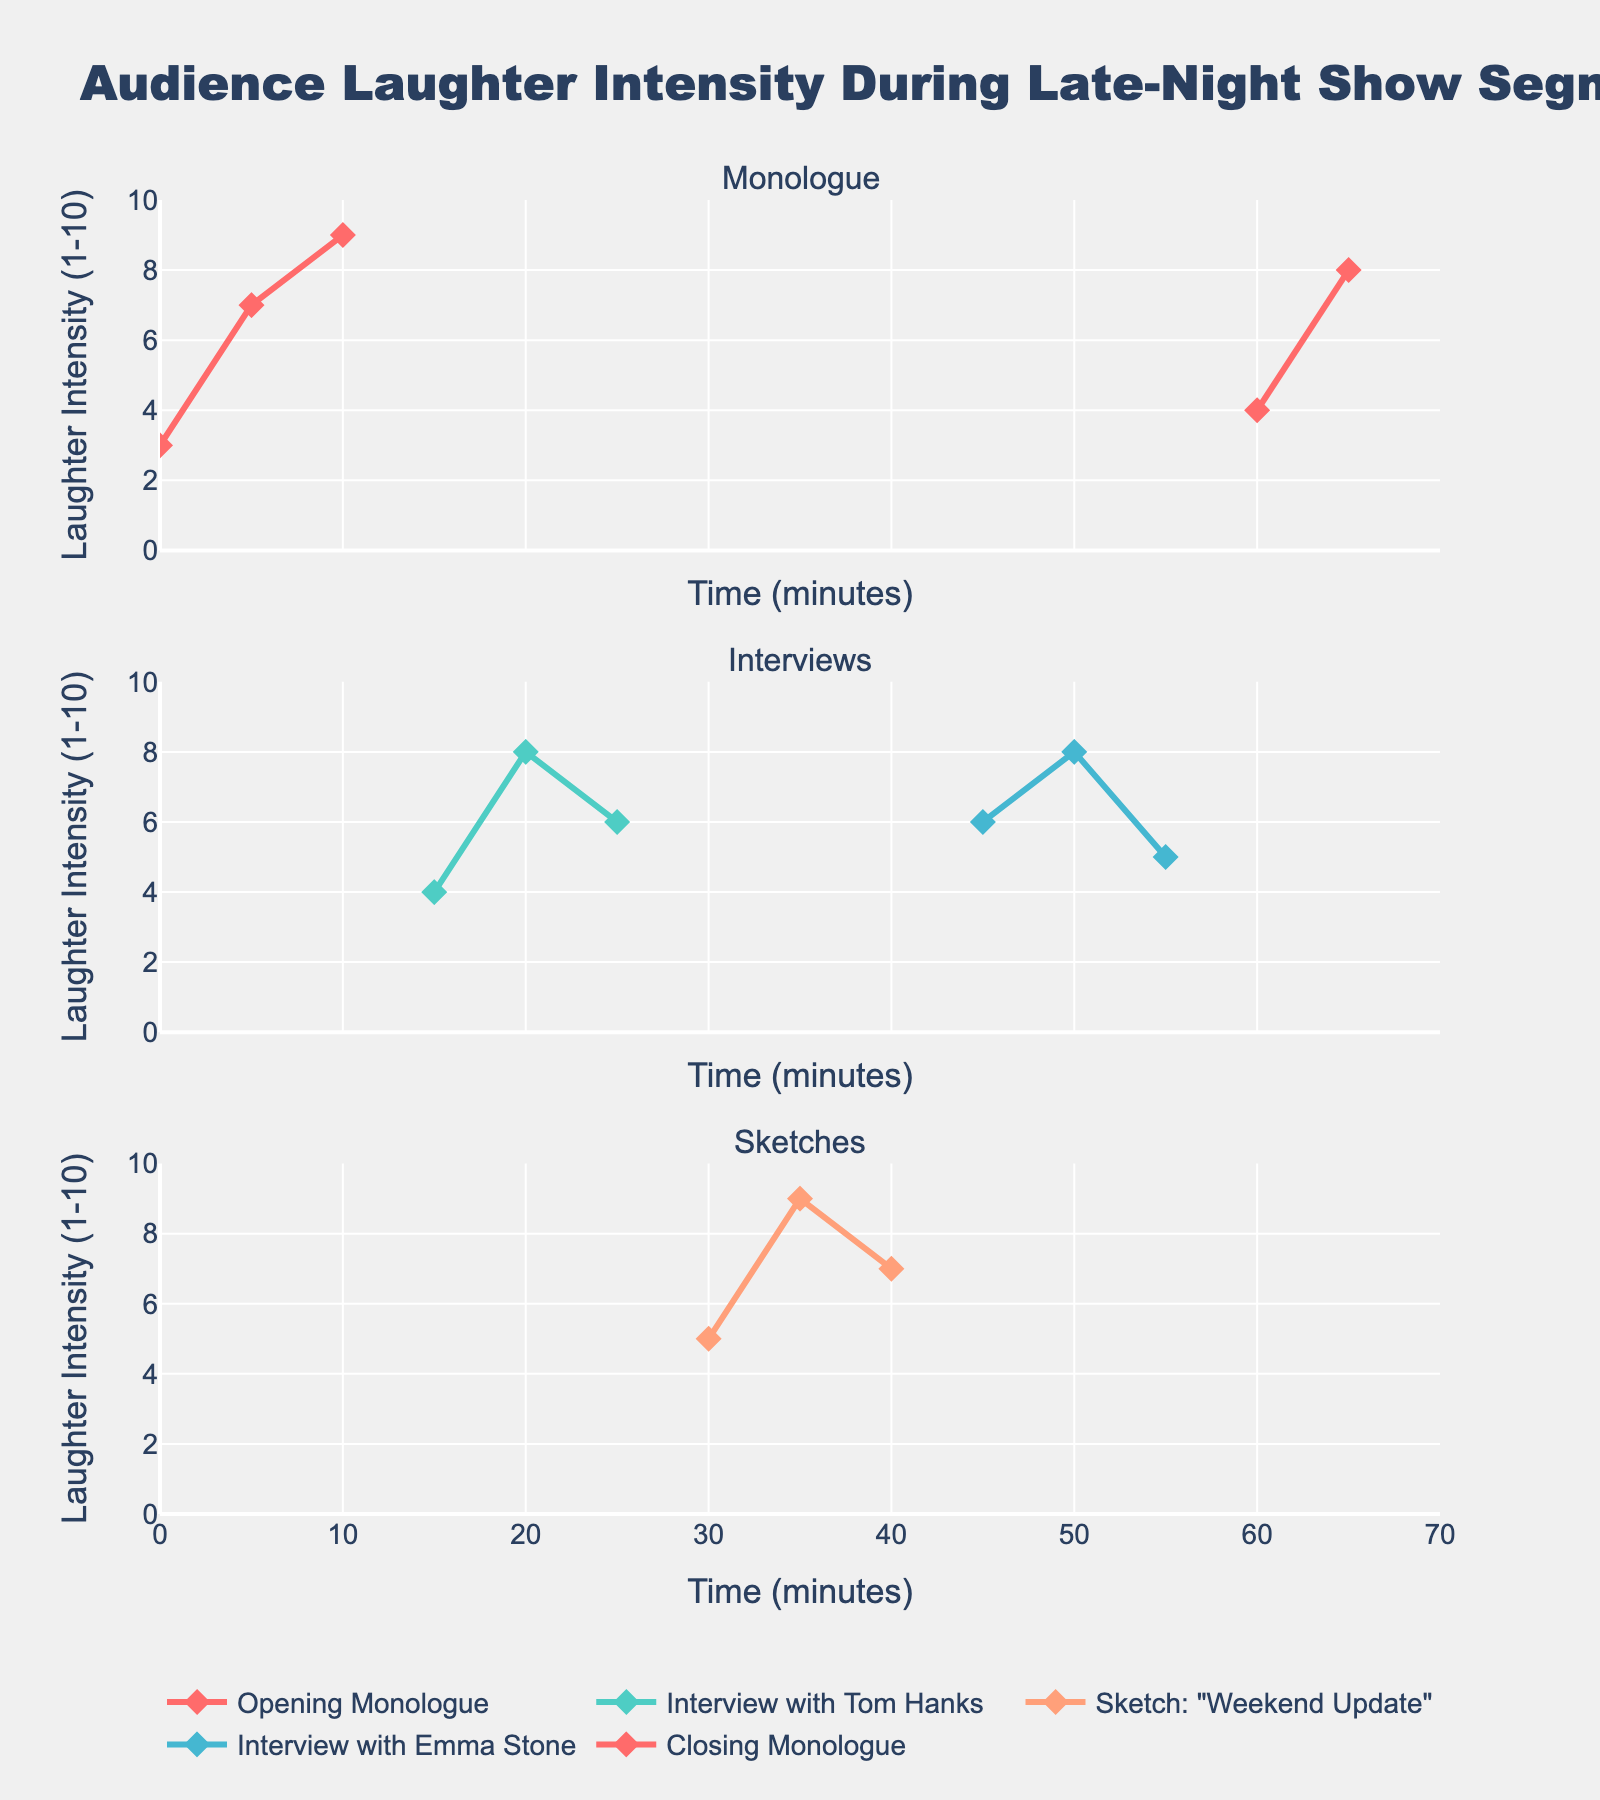What's the title of the plot? The title of the plot is located at the top of the figure and reads "Audience Laughter Intensity During Late-Night Show Segments".
Answer: Audience Laughter Intensity During Late-Night Show Segments How many segments are displayed in the figure? The figure displays five segments: Opening Monologue, Interview with Tom Hanks, Sketch "Weekend Update", Interview with Emma Stone, and Closing Monologue.
Answer: 5 What's the highest laughter intensity recorded during the Sketch "Weekend Update"? For the Sketch "Weekend Update", the laughter intensities are 5, 9, and 7. The highest among these is 9.
Answer: 9 Between which two time points does the Opening Monologue show the highest increase in laughter intensity? The Opening Monologue segment shows data at 0, 5, and 10 minutes with laughter intensities of 3, 7, and 9 respectively. The highest increase is between 0 to 5 minutes where intensity increases by 4 (7-3).
Answer: 0 to 5 minutes Which interview segment exhibits more fluctuation in laughter intensity? The Interview with Tom Hanks has laughter intensities of 4, 8, and 6, while Interview with Emma Stone has 6, 8, and 5. The fluctuation range for Tom Hanks is 4 (8-4) and for Emma Stone is 3 (8-5). Hence, Interview with Tom Hanks has more fluctuation.
Answer: Interview with Tom Hanks What is the average laughter intensity during the Interview with Emma Stone? Laughter intensities during the Interview with Emma Stone are 6, 8, and 5. Their sum is 19, and the average is 19/3 ≈ 6.33.
Answer: 6.33 Which monologue segment, Opening or Closing, has a higher average laughter intensity? The Opening Monologue laughter intensities are 3, 7, and 9. Average = (3+7+9)/3 = 6.33. The Closing Monologue intensities are 4 and 8. Average = (4+8)/2 = 6. The Opening Monologue has a higher average.
Answer: Opening Monologue At what time point was the highest overall laughter intensity recorded? Checking all segments, the highest intensity recorded is 9, which appears at 10 minutes in the Opening Monologue and at 35 minutes in Sketch "Weekend Update".
Answer: 10 minutes and 35 minutes How does the laughter intensity trend for the Opening Monologue compare with that of the Closing Monologue? The Opening Monologue shows an increasing trend going from 3 to 7 to 9, while the Closing Monologue shows an increasing trend from 4 to 8 but has fewer data points.
Answer: Both increase, Opening Monologue has more data points What's the total number of data points in the entire figure? Counting data points from each segment: Opening Monologue (3), Interview with Tom Hanks (3), Sketch "Weekend Update" (3), Interview with Emma Stone (3), Closing Monologue (2). The total number of data points is 3+3+3+3+2 = 14.
Answer: 14 